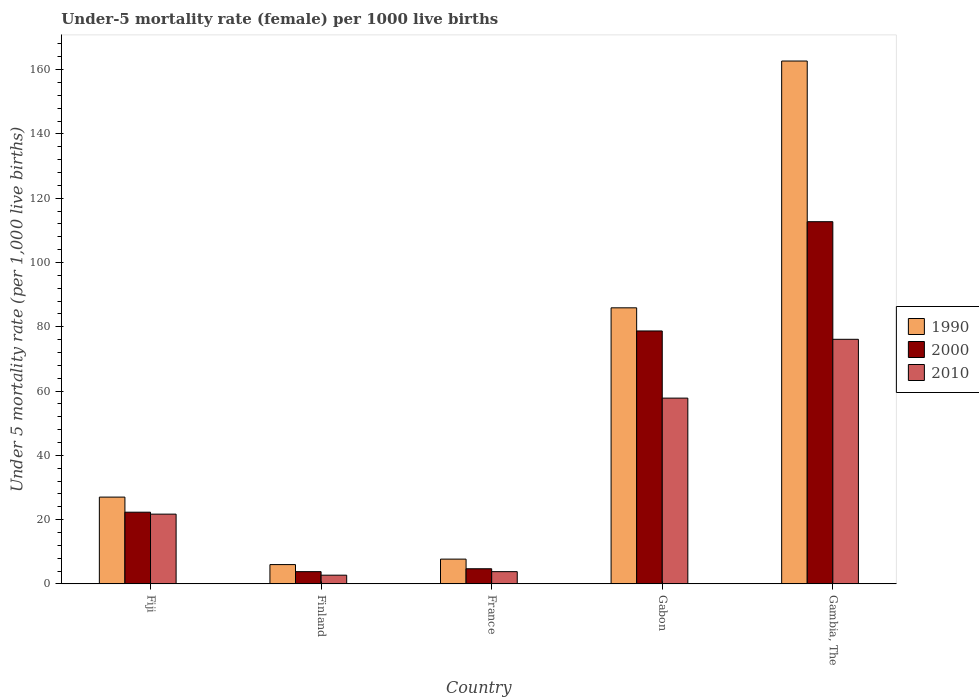How many groups of bars are there?
Your answer should be compact. 5. Are the number of bars per tick equal to the number of legend labels?
Give a very brief answer. Yes. Are the number of bars on each tick of the X-axis equal?
Make the answer very short. Yes. How many bars are there on the 3rd tick from the right?
Your answer should be compact. 3. What is the label of the 2nd group of bars from the left?
Give a very brief answer. Finland. In how many cases, is the number of bars for a given country not equal to the number of legend labels?
Your response must be concise. 0. What is the under-five mortality rate in 2000 in France?
Provide a short and direct response. 4.7. Across all countries, what is the maximum under-five mortality rate in 1990?
Make the answer very short. 162.7. In which country was the under-five mortality rate in 1990 maximum?
Provide a short and direct response. Gambia, The. In which country was the under-five mortality rate in 1990 minimum?
Provide a short and direct response. Finland. What is the total under-five mortality rate in 2010 in the graph?
Keep it short and to the point. 162.1. What is the difference between the under-five mortality rate in 2010 in Finland and that in France?
Provide a succinct answer. -1.1. What is the difference between the under-five mortality rate in 2010 in France and the under-five mortality rate in 2000 in Gabon?
Ensure brevity in your answer.  -74.9. What is the average under-five mortality rate in 1990 per country?
Keep it short and to the point. 57.86. What is the difference between the under-five mortality rate of/in 2000 and under-five mortality rate of/in 2010 in France?
Keep it short and to the point. 0.9. In how many countries, is the under-five mortality rate in 2000 greater than 32?
Your response must be concise. 2. What is the ratio of the under-five mortality rate in 2010 in Fiji to that in Finland?
Your response must be concise. 8.04. Is the under-five mortality rate in 2010 in Fiji less than that in France?
Your answer should be compact. No. Is the difference between the under-five mortality rate in 2000 in France and Gabon greater than the difference between the under-five mortality rate in 2010 in France and Gabon?
Make the answer very short. No. What is the difference between the highest and the lowest under-five mortality rate in 1990?
Ensure brevity in your answer.  156.7. In how many countries, is the under-five mortality rate in 2010 greater than the average under-five mortality rate in 2010 taken over all countries?
Ensure brevity in your answer.  2. What does the 1st bar from the right in France represents?
Provide a short and direct response. 2010. Are the values on the major ticks of Y-axis written in scientific E-notation?
Provide a short and direct response. No. Does the graph contain grids?
Your answer should be compact. No. How many legend labels are there?
Your response must be concise. 3. How are the legend labels stacked?
Your response must be concise. Vertical. What is the title of the graph?
Provide a succinct answer. Under-5 mortality rate (female) per 1000 live births. What is the label or title of the Y-axis?
Keep it short and to the point. Under 5 mortality rate (per 1,0 live births). What is the Under 5 mortality rate (per 1,000 live births) of 2000 in Fiji?
Provide a short and direct response. 22.3. What is the Under 5 mortality rate (per 1,000 live births) of 2010 in Fiji?
Keep it short and to the point. 21.7. What is the Under 5 mortality rate (per 1,000 live births) of 1990 in Finland?
Provide a succinct answer. 6. What is the Under 5 mortality rate (per 1,000 live births) in 2010 in Finland?
Offer a terse response. 2.7. What is the Under 5 mortality rate (per 1,000 live births) in 1990 in France?
Your response must be concise. 7.7. What is the Under 5 mortality rate (per 1,000 live births) in 1990 in Gabon?
Give a very brief answer. 85.9. What is the Under 5 mortality rate (per 1,000 live births) of 2000 in Gabon?
Keep it short and to the point. 78.7. What is the Under 5 mortality rate (per 1,000 live births) in 2010 in Gabon?
Give a very brief answer. 57.8. What is the Under 5 mortality rate (per 1,000 live births) in 1990 in Gambia, The?
Ensure brevity in your answer.  162.7. What is the Under 5 mortality rate (per 1,000 live births) in 2000 in Gambia, The?
Provide a short and direct response. 112.7. What is the Under 5 mortality rate (per 1,000 live births) of 2010 in Gambia, The?
Provide a short and direct response. 76.1. Across all countries, what is the maximum Under 5 mortality rate (per 1,000 live births) of 1990?
Give a very brief answer. 162.7. Across all countries, what is the maximum Under 5 mortality rate (per 1,000 live births) of 2000?
Offer a very short reply. 112.7. Across all countries, what is the maximum Under 5 mortality rate (per 1,000 live births) of 2010?
Your response must be concise. 76.1. Across all countries, what is the minimum Under 5 mortality rate (per 1,000 live births) in 2000?
Give a very brief answer. 3.8. What is the total Under 5 mortality rate (per 1,000 live births) in 1990 in the graph?
Your answer should be compact. 289.3. What is the total Under 5 mortality rate (per 1,000 live births) of 2000 in the graph?
Give a very brief answer. 222.2. What is the total Under 5 mortality rate (per 1,000 live births) in 2010 in the graph?
Offer a very short reply. 162.1. What is the difference between the Under 5 mortality rate (per 1,000 live births) in 2000 in Fiji and that in Finland?
Your response must be concise. 18.5. What is the difference between the Under 5 mortality rate (per 1,000 live births) of 1990 in Fiji and that in France?
Give a very brief answer. 19.3. What is the difference between the Under 5 mortality rate (per 1,000 live births) of 2000 in Fiji and that in France?
Offer a terse response. 17.6. What is the difference between the Under 5 mortality rate (per 1,000 live births) in 2010 in Fiji and that in France?
Provide a short and direct response. 17.9. What is the difference between the Under 5 mortality rate (per 1,000 live births) of 1990 in Fiji and that in Gabon?
Your answer should be very brief. -58.9. What is the difference between the Under 5 mortality rate (per 1,000 live births) of 2000 in Fiji and that in Gabon?
Your answer should be very brief. -56.4. What is the difference between the Under 5 mortality rate (per 1,000 live births) in 2010 in Fiji and that in Gabon?
Your answer should be compact. -36.1. What is the difference between the Under 5 mortality rate (per 1,000 live births) of 1990 in Fiji and that in Gambia, The?
Your answer should be compact. -135.7. What is the difference between the Under 5 mortality rate (per 1,000 live births) in 2000 in Fiji and that in Gambia, The?
Your answer should be very brief. -90.4. What is the difference between the Under 5 mortality rate (per 1,000 live births) of 2010 in Fiji and that in Gambia, The?
Your answer should be compact. -54.4. What is the difference between the Under 5 mortality rate (per 1,000 live births) in 1990 in Finland and that in France?
Make the answer very short. -1.7. What is the difference between the Under 5 mortality rate (per 1,000 live births) of 2000 in Finland and that in France?
Make the answer very short. -0.9. What is the difference between the Under 5 mortality rate (per 1,000 live births) in 2010 in Finland and that in France?
Make the answer very short. -1.1. What is the difference between the Under 5 mortality rate (per 1,000 live births) of 1990 in Finland and that in Gabon?
Give a very brief answer. -79.9. What is the difference between the Under 5 mortality rate (per 1,000 live births) in 2000 in Finland and that in Gabon?
Ensure brevity in your answer.  -74.9. What is the difference between the Under 5 mortality rate (per 1,000 live births) in 2010 in Finland and that in Gabon?
Your answer should be compact. -55.1. What is the difference between the Under 5 mortality rate (per 1,000 live births) of 1990 in Finland and that in Gambia, The?
Make the answer very short. -156.7. What is the difference between the Under 5 mortality rate (per 1,000 live births) of 2000 in Finland and that in Gambia, The?
Keep it short and to the point. -108.9. What is the difference between the Under 5 mortality rate (per 1,000 live births) in 2010 in Finland and that in Gambia, The?
Ensure brevity in your answer.  -73.4. What is the difference between the Under 5 mortality rate (per 1,000 live births) in 1990 in France and that in Gabon?
Your response must be concise. -78.2. What is the difference between the Under 5 mortality rate (per 1,000 live births) in 2000 in France and that in Gabon?
Your answer should be compact. -74. What is the difference between the Under 5 mortality rate (per 1,000 live births) in 2010 in France and that in Gabon?
Offer a terse response. -54. What is the difference between the Under 5 mortality rate (per 1,000 live births) of 1990 in France and that in Gambia, The?
Give a very brief answer. -155. What is the difference between the Under 5 mortality rate (per 1,000 live births) of 2000 in France and that in Gambia, The?
Your answer should be compact. -108. What is the difference between the Under 5 mortality rate (per 1,000 live births) of 2010 in France and that in Gambia, The?
Keep it short and to the point. -72.3. What is the difference between the Under 5 mortality rate (per 1,000 live births) of 1990 in Gabon and that in Gambia, The?
Provide a short and direct response. -76.8. What is the difference between the Under 5 mortality rate (per 1,000 live births) of 2000 in Gabon and that in Gambia, The?
Make the answer very short. -34. What is the difference between the Under 5 mortality rate (per 1,000 live births) in 2010 in Gabon and that in Gambia, The?
Ensure brevity in your answer.  -18.3. What is the difference between the Under 5 mortality rate (per 1,000 live births) in 1990 in Fiji and the Under 5 mortality rate (per 1,000 live births) in 2000 in Finland?
Your response must be concise. 23.2. What is the difference between the Under 5 mortality rate (per 1,000 live births) in 1990 in Fiji and the Under 5 mortality rate (per 1,000 live births) in 2010 in Finland?
Make the answer very short. 24.3. What is the difference between the Under 5 mortality rate (per 1,000 live births) of 2000 in Fiji and the Under 5 mortality rate (per 1,000 live births) of 2010 in Finland?
Offer a terse response. 19.6. What is the difference between the Under 5 mortality rate (per 1,000 live births) of 1990 in Fiji and the Under 5 mortality rate (per 1,000 live births) of 2000 in France?
Offer a very short reply. 22.3. What is the difference between the Under 5 mortality rate (per 1,000 live births) of 1990 in Fiji and the Under 5 mortality rate (per 1,000 live births) of 2010 in France?
Your answer should be compact. 23.2. What is the difference between the Under 5 mortality rate (per 1,000 live births) in 1990 in Fiji and the Under 5 mortality rate (per 1,000 live births) in 2000 in Gabon?
Provide a short and direct response. -51.7. What is the difference between the Under 5 mortality rate (per 1,000 live births) of 1990 in Fiji and the Under 5 mortality rate (per 1,000 live births) of 2010 in Gabon?
Offer a terse response. -30.8. What is the difference between the Under 5 mortality rate (per 1,000 live births) in 2000 in Fiji and the Under 5 mortality rate (per 1,000 live births) in 2010 in Gabon?
Give a very brief answer. -35.5. What is the difference between the Under 5 mortality rate (per 1,000 live births) in 1990 in Fiji and the Under 5 mortality rate (per 1,000 live births) in 2000 in Gambia, The?
Provide a succinct answer. -85.7. What is the difference between the Under 5 mortality rate (per 1,000 live births) in 1990 in Fiji and the Under 5 mortality rate (per 1,000 live births) in 2010 in Gambia, The?
Your answer should be compact. -49.1. What is the difference between the Under 5 mortality rate (per 1,000 live births) of 2000 in Fiji and the Under 5 mortality rate (per 1,000 live births) of 2010 in Gambia, The?
Provide a short and direct response. -53.8. What is the difference between the Under 5 mortality rate (per 1,000 live births) of 1990 in Finland and the Under 5 mortality rate (per 1,000 live births) of 2000 in France?
Your response must be concise. 1.3. What is the difference between the Under 5 mortality rate (per 1,000 live births) of 1990 in Finland and the Under 5 mortality rate (per 1,000 live births) of 2000 in Gabon?
Ensure brevity in your answer.  -72.7. What is the difference between the Under 5 mortality rate (per 1,000 live births) of 1990 in Finland and the Under 5 mortality rate (per 1,000 live births) of 2010 in Gabon?
Offer a terse response. -51.8. What is the difference between the Under 5 mortality rate (per 1,000 live births) in 2000 in Finland and the Under 5 mortality rate (per 1,000 live births) in 2010 in Gabon?
Offer a terse response. -54. What is the difference between the Under 5 mortality rate (per 1,000 live births) in 1990 in Finland and the Under 5 mortality rate (per 1,000 live births) in 2000 in Gambia, The?
Ensure brevity in your answer.  -106.7. What is the difference between the Under 5 mortality rate (per 1,000 live births) in 1990 in Finland and the Under 5 mortality rate (per 1,000 live births) in 2010 in Gambia, The?
Your answer should be very brief. -70.1. What is the difference between the Under 5 mortality rate (per 1,000 live births) of 2000 in Finland and the Under 5 mortality rate (per 1,000 live births) of 2010 in Gambia, The?
Give a very brief answer. -72.3. What is the difference between the Under 5 mortality rate (per 1,000 live births) of 1990 in France and the Under 5 mortality rate (per 1,000 live births) of 2000 in Gabon?
Make the answer very short. -71. What is the difference between the Under 5 mortality rate (per 1,000 live births) of 1990 in France and the Under 5 mortality rate (per 1,000 live births) of 2010 in Gabon?
Give a very brief answer. -50.1. What is the difference between the Under 5 mortality rate (per 1,000 live births) of 2000 in France and the Under 5 mortality rate (per 1,000 live births) of 2010 in Gabon?
Give a very brief answer. -53.1. What is the difference between the Under 5 mortality rate (per 1,000 live births) in 1990 in France and the Under 5 mortality rate (per 1,000 live births) in 2000 in Gambia, The?
Your answer should be compact. -105. What is the difference between the Under 5 mortality rate (per 1,000 live births) of 1990 in France and the Under 5 mortality rate (per 1,000 live births) of 2010 in Gambia, The?
Offer a terse response. -68.4. What is the difference between the Under 5 mortality rate (per 1,000 live births) in 2000 in France and the Under 5 mortality rate (per 1,000 live births) in 2010 in Gambia, The?
Your answer should be compact. -71.4. What is the difference between the Under 5 mortality rate (per 1,000 live births) of 1990 in Gabon and the Under 5 mortality rate (per 1,000 live births) of 2000 in Gambia, The?
Provide a short and direct response. -26.8. What is the average Under 5 mortality rate (per 1,000 live births) of 1990 per country?
Provide a short and direct response. 57.86. What is the average Under 5 mortality rate (per 1,000 live births) in 2000 per country?
Your answer should be compact. 44.44. What is the average Under 5 mortality rate (per 1,000 live births) of 2010 per country?
Your response must be concise. 32.42. What is the difference between the Under 5 mortality rate (per 1,000 live births) of 1990 and Under 5 mortality rate (per 1,000 live births) of 2000 in Fiji?
Your answer should be very brief. 4.7. What is the difference between the Under 5 mortality rate (per 1,000 live births) of 1990 and Under 5 mortality rate (per 1,000 live births) of 2010 in Fiji?
Keep it short and to the point. 5.3. What is the difference between the Under 5 mortality rate (per 1,000 live births) of 1990 and Under 5 mortality rate (per 1,000 live births) of 2000 in Finland?
Give a very brief answer. 2.2. What is the difference between the Under 5 mortality rate (per 1,000 live births) in 1990 and Under 5 mortality rate (per 1,000 live births) in 2010 in Finland?
Give a very brief answer. 3.3. What is the difference between the Under 5 mortality rate (per 1,000 live births) of 1990 and Under 5 mortality rate (per 1,000 live births) of 2000 in France?
Your response must be concise. 3. What is the difference between the Under 5 mortality rate (per 1,000 live births) in 2000 and Under 5 mortality rate (per 1,000 live births) in 2010 in France?
Your answer should be compact. 0.9. What is the difference between the Under 5 mortality rate (per 1,000 live births) of 1990 and Under 5 mortality rate (per 1,000 live births) of 2000 in Gabon?
Provide a short and direct response. 7.2. What is the difference between the Under 5 mortality rate (per 1,000 live births) of 1990 and Under 5 mortality rate (per 1,000 live births) of 2010 in Gabon?
Provide a succinct answer. 28.1. What is the difference between the Under 5 mortality rate (per 1,000 live births) of 2000 and Under 5 mortality rate (per 1,000 live births) of 2010 in Gabon?
Provide a short and direct response. 20.9. What is the difference between the Under 5 mortality rate (per 1,000 live births) in 1990 and Under 5 mortality rate (per 1,000 live births) in 2010 in Gambia, The?
Ensure brevity in your answer.  86.6. What is the difference between the Under 5 mortality rate (per 1,000 live births) in 2000 and Under 5 mortality rate (per 1,000 live births) in 2010 in Gambia, The?
Provide a succinct answer. 36.6. What is the ratio of the Under 5 mortality rate (per 1,000 live births) of 2000 in Fiji to that in Finland?
Offer a very short reply. 5.87. What is the ratio of the Under 5 mortality rate (per 1,000 live births) in 2010 in Fiji to that in Finland?
Your answer should be very brief. 8.04. What is the ratio of the Under 5 mortality rate (per 1,000 live births) of 1990 in Fiji to that in France?
Ensure brevity in your answer.  3.51. What is the ratio of the Under 5 mortality rate (per 1,000 live births) of 2000 in Fiji to that in France?
Your answer should be compact. 4.74. What is the ratio of the Under 5 mortality rate (per 1,000 live births) of 2010 in Fiji to that in France?
Ensure brevity in your answer.  5.71. What is the ratio of the Under 5 mortality rate (per 1,000 live births) in 1990 in Fiji to that in Gabon?
Offer a terse response. 0.31. What is the ratio of the Under 5 mortality rate (per 1,000 live births) of 2000 in Fiji to that in Gabon?
Give a very brief answer. 0.28. What is the ratio of the Under 5 mortality rate (per 1,000 live births) in 2010 in Fiji to that in Gabon?
Your response must be concise. 0.38. What is the ratio of the Under 5 mortality rate (per 1,000 live births) in 1990 in Fiji to that in Gambia, The?
Provide a succinct answer. 0.17. What is the ratio of the Under 5 mortality rate (per 1,000 live births) in 2000 in Fiji to that in Gambia, The?
Your answer should be very brief. 0.2. What is the ratio of the Under 5 mortality rate (per 1,000 live births) in 2010 in Fiji to that in Gambia, The?
Your answer should be compact. 0.29. What is the ratio of the Under 5 mortality rate (per 1,000 live births) of 1990 in Finland to that in France?
Provide a succinct answer. 0.78. What is the ratio of the Under 5 mortality rate (per 1,000 live births) in 2000 in Finland to that in France?
Your answer should be very brief. 0.81. What is the ratio of the Under 5 mortality rate (per 1,000 live births) in 2010 in Finland to that in France?
Your answer should be compact. 0.71. What is the ratio of the Under 5 mortality rate (per 1,000 live births) of 1990 in Finland to that in Gabon?
Keep it short and to the point. 0.07. What is the ratio of the Under 5 mortality rate (per 1,000 live births) in 2000 in Finland to that in Gabon?
Keep it short and to the point. 0.05. What is the ratio of the Under 5 mortality rate (per 1,000 live births) of 2010 in Finland to that in Gabon?
Keep it short and to the point. 0.05. What is the ratio of the Under 5 mortality rate (per 1,000 live births) of 1990 in Finland to that in Gambia, The?
Make the answer very short. 0.04. What is the ratio of the Under 5 mortality rate (per 1,000 live births) in 2000 in Finland to that in Gambia, The?
Your answer should be compact. 0.03. What is the ratio of the Under 5 mortality rate (per 1,000 live births) in 2010 in Finland to that in Gambia, The?
Your answer should be very brief. 0.04. What is the ratio of the Under 5 mortality rate (per 1,000 live births) in 1990 in France to that in Gabon?
Your answer should be very brief. 0.09. What is the ratio of the Under 5 mortality rate (per 1,000 live births) in 2000 in France to that in Gabon?
Your answer should be very brief. 0.06. What is the ratio of the Under 5 mortality rate (per 1,000 live births) in 2010 in France to that in Gabon?
Offer a very short reply. 0.07. What is the ratio of the Under 5 mortality rate (per 1,000 live births) in 1990 in France to that in Gambia, The?
Ensure brevity in your answer.  0.05. What is the ratio of the Under 5 mortality rate (per 1,000 live births) in 2000 in France to that in Gambia, The?
Offer a very short reply. 0.04. What is the ratio of the Under 5 mortality rate (per 1,000 live births) in 2010 in France to that in Gambia, The?
Your answer should be compact. 0.05. What is the ratio of the Under 5 mortality rate (per 1,000 live births) of 1990 in Gabon to that in Gambia, The?
Give a very brief answer. 0.53. What is the ratio of the Under 5 mortality rate (per 1,000 live births) of 2000 in Gabon to that in Gambia, The?
Your answer should be compact. 0.7. What is the ratio of the Under 5 mortality rate (per 1,000 live births) in 2010 in Gabon to that in Gambia, The?
Provide a succinct answer. 0.76. What is the difference between the highest and the second highest Under 5 mortality rate (per 1,000 live births) in 1990?
Ensure brevity in your answer.  76.8. What is the difference between the highest and the second highest Under 5 mortality rate (per 1,000 live births) of 2000?
Give a very brief answer. 34. What is the difference between the highest and the lowest Under 5 mortality rate (per 1,000 live births) of 1990?
Your response must be concise. 156.7. What is the difference between the highest and the lowest Under 5 mortality rate (per 1,000 live births) in 2000?
Your answer should be very brief. 108.9. What is the difference between the highest and the lowest Under 5 mortality rate (per 1,000 live births) in 2010?
Keep it short and to the point. 73.4. 